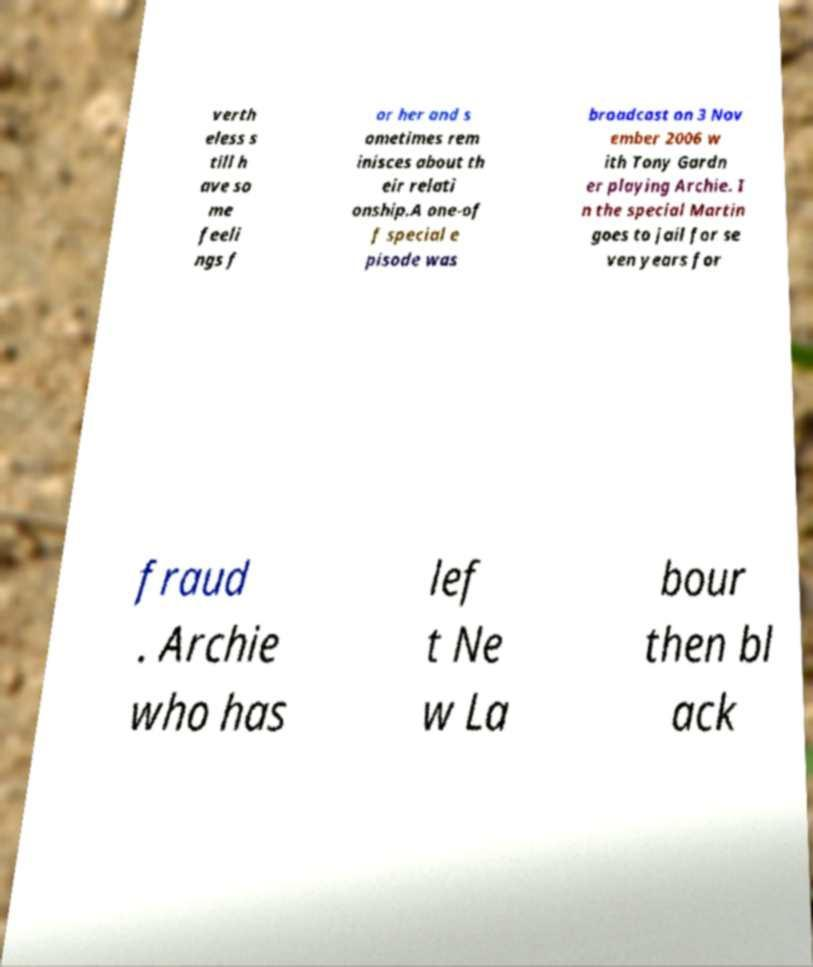Can you accurately transcribe the text from the provided image for me? verth eless s till h ave so me feeli ngs f or her and s ometimes rem inisces about th eir relati onship.A one-of f special e pisode was broadcast on 3 Nov ember 2006 w ith Tony Gardn er playing Archie. I n the special Martin goes to jail for se ven years for fraud . Archie who has lef t Ne w La bour then bl ack 